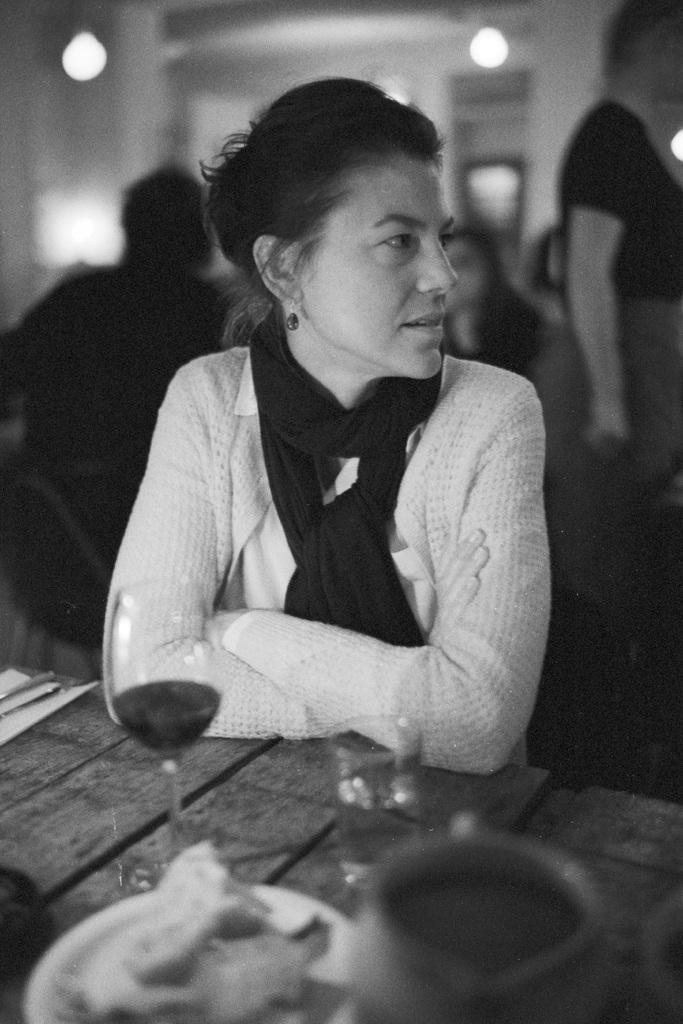Who is present in the image? There is a woman in the image. What is located near the woman? There is a table in the image. What can be seen on the table? There is a glass and a cup on the table. What else can be observed in the background of the image? There are other people and lights visible in the background of the image. What type of pet is crawling on the table in the image? There is no pet visible on the table in the image. 